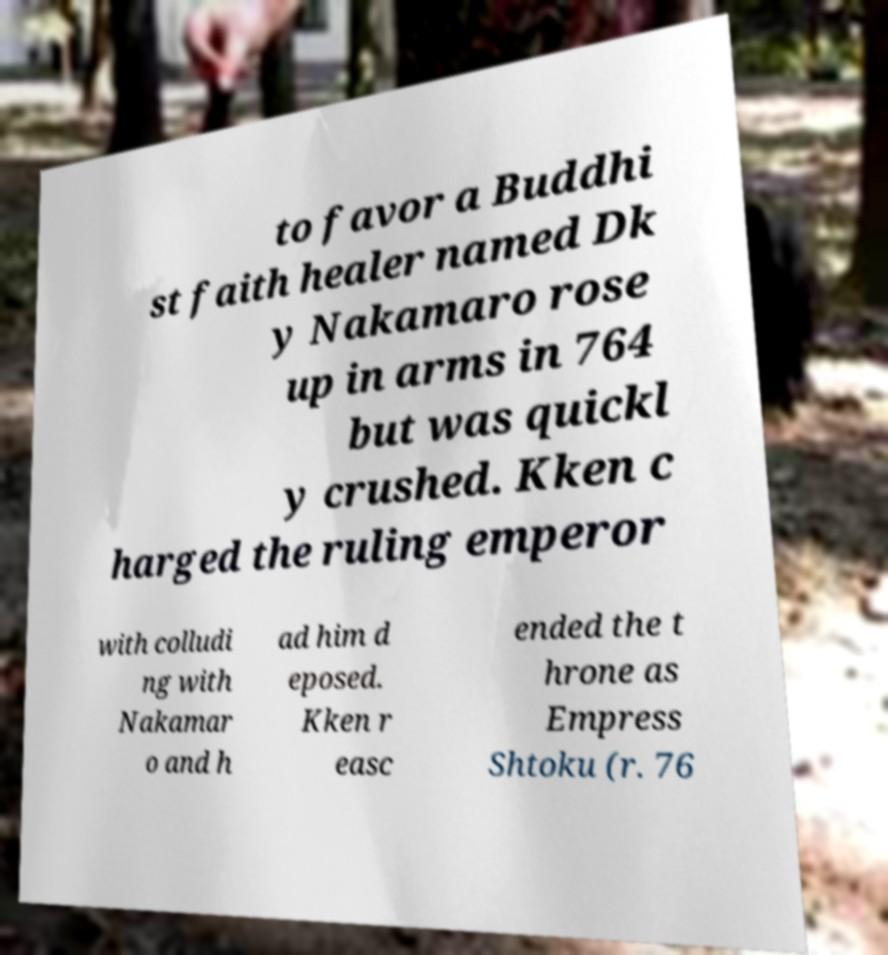There's text embedded in this image that I need extracted. Can you transcribe it verbatim? to favor a Buddhi st faith healer named Dk y Nakamaro rose up in arms in 764 but was quickl y crushed. Kken c harged the ruling emperor with colludi ng with Nakamar o and h ad him d eposed. Kken r easc ended the t hrone as Empress Shtoku (r. 76 